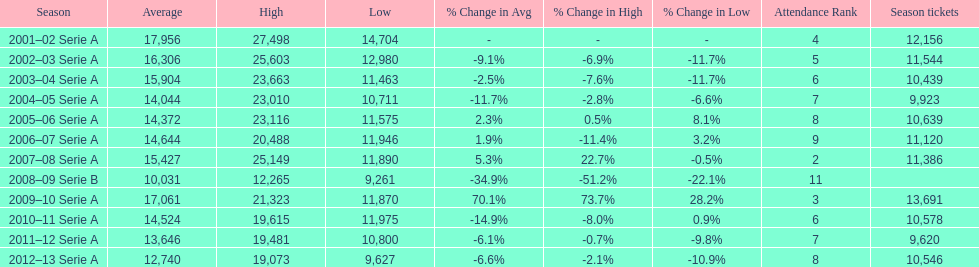What was the average attendance in 2008? 10,031. 